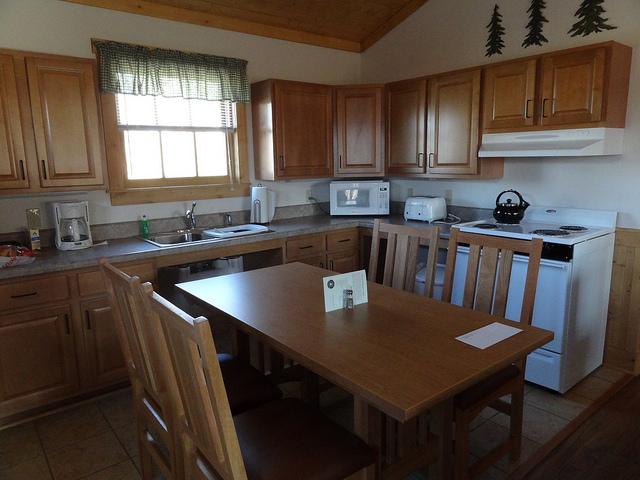Are the cabinets open?
Give a very brief answer. No. Is the stove new?
Give a very brief answer. No. What color is the microwave?
Answer briefly. White. How many cabinets are directly above the microwave?
Answer briefly. 1. What color are the curtains?
Concise answer only. Green. Where is the microwave?
Answer briefly. Counter. Does this kitchen have an island?
Short answer required. No. Was this kitchen just remodeled?
Quick response, please. No. What electronic device hangs from the far right wall?
Short answer required. Clock. Does the table and chairs match the cabinets?
Answer briefly. Yes. How many chairs are there at the table?
Write a very short answer. 4. How many chairs in this picture?
Give a very brief answer. 4. How many ovens does this kitchen have?
Keep it brief. 1. Is there any coffee in the coffee maker?
Give a very brief answer. No. What color is the tea kettle?
Give a very brief answer. Black. What design has the table cover?
Write a very short answer. None. 